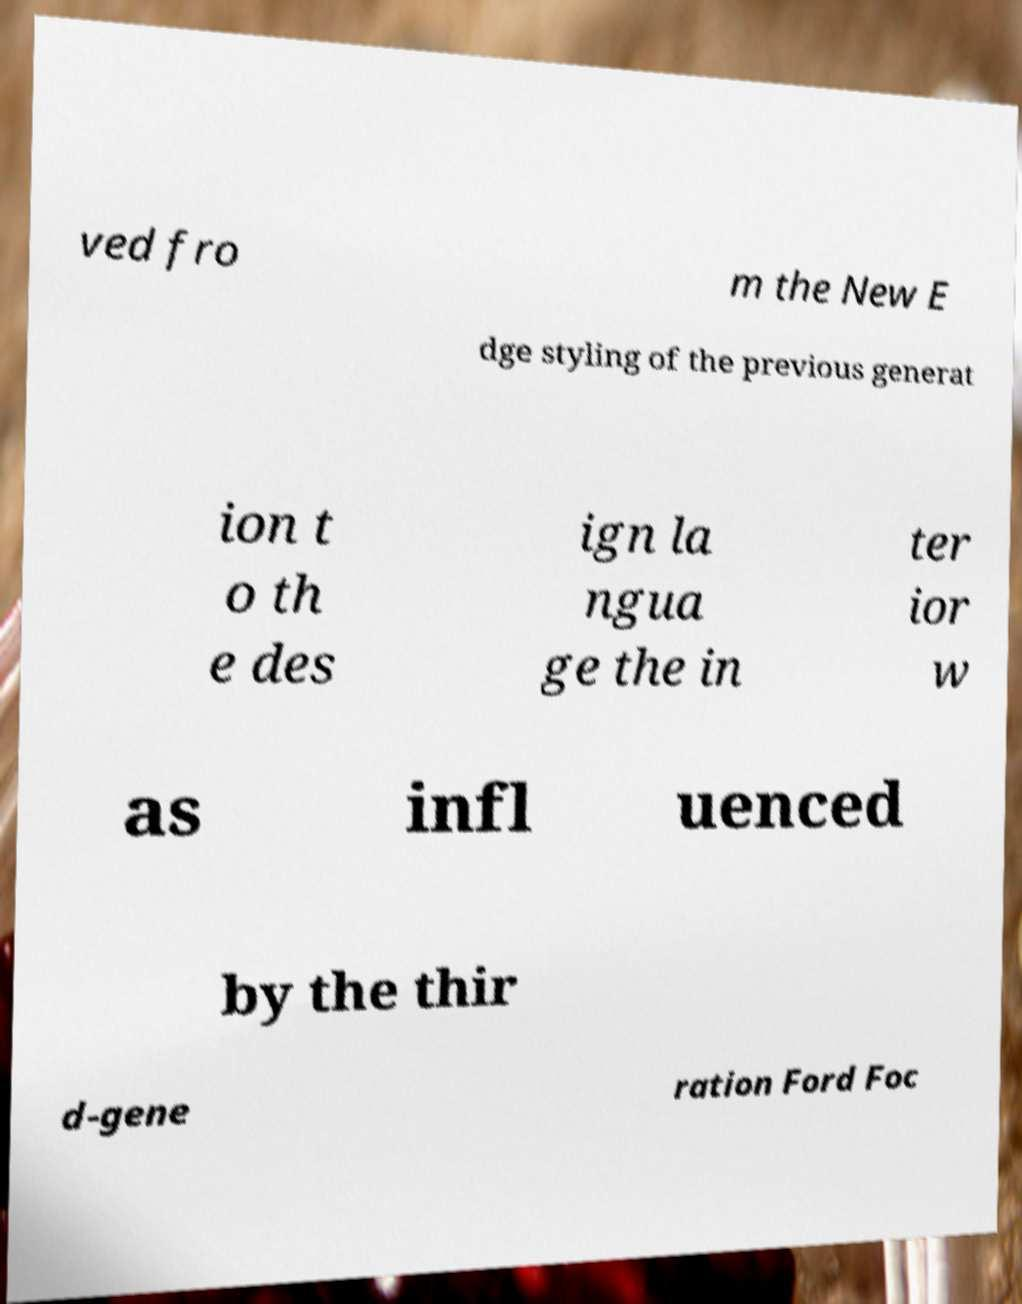There's text embedded in this image that I need extracted. Can you transcribe it verbatim? ved fro m the New E dge styling of the previous generat ion t o th e des ign la ngua ge the in ter ior w as infl uenced by the thir d-gene ration Ford Foc 